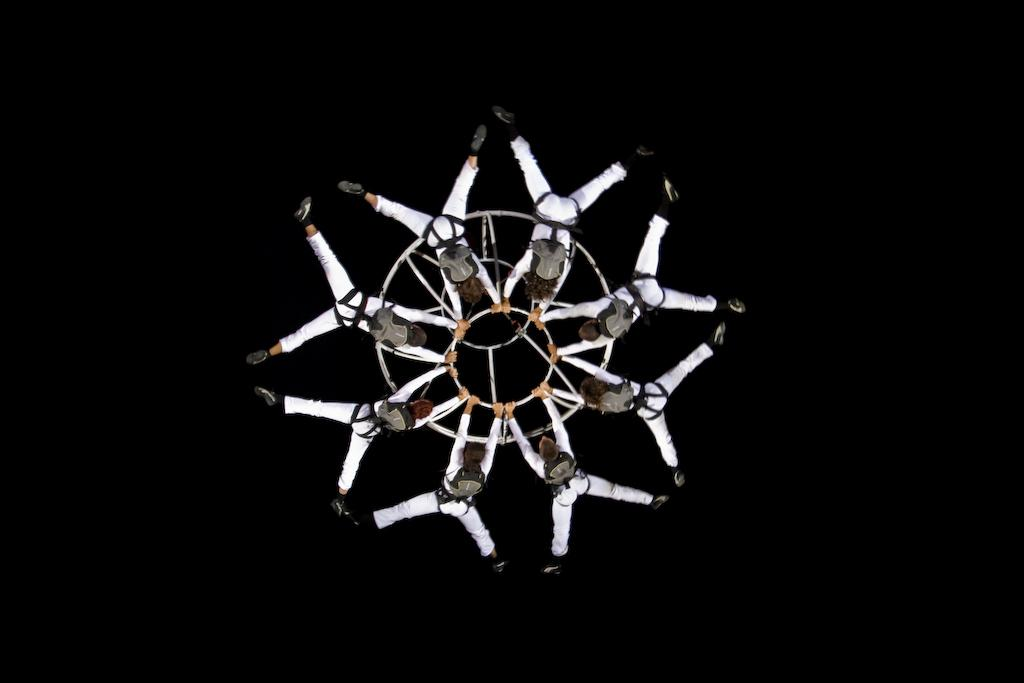Who or what can be seen in the image? There are people in the image. How are the people positioned in the image? The people are hanging with the help of an object. What can be observed about the lighting in the image? The background of the image is dark. What type of wren can be seen in the garden aftermath in the image? There is no wren or garden present in the image; it features people hanging with the help of an object against a dark background. 